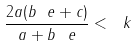Convert formula to latex. <formula><loc_0><loc_0><loc_500><loc_500>\frac { 2 a ( b _ { \ } e + c ) } { a + b _ { \ } e } < \ k</formula> 